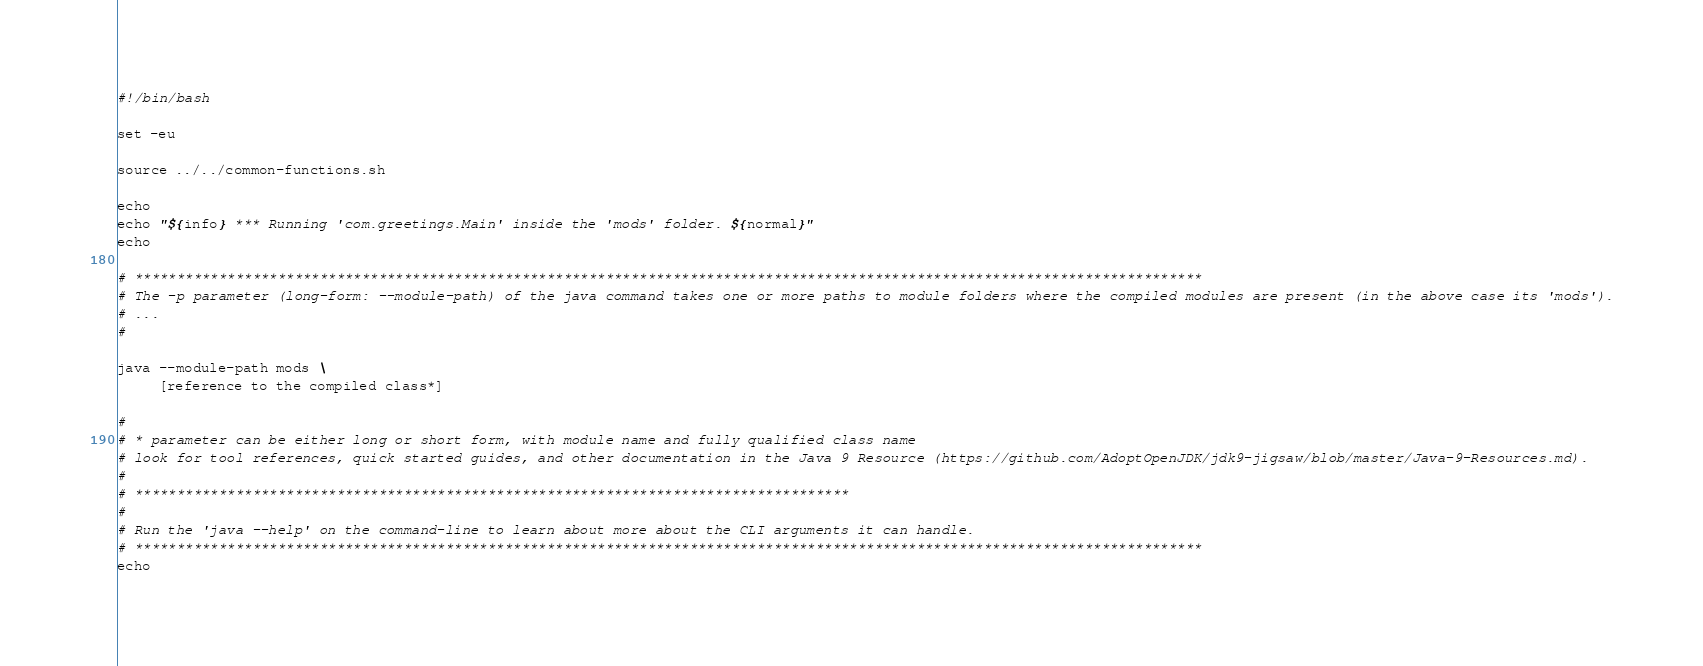Convert code to text. <code><loc_0><loc_0><loc_500><loc_500><_Bash_>#!/bin/bash

set -eu

source ../../common-functions.sh

echo 
echo "${info} *** Running 'com.greetings.Main' inside the 'mods' folder. ${normal}"
echo

# *******************************************************************************************************************************
# The -p parameter (long-form: --module-path) of the java command takes one or more paths to module folders where the compiled modules are present (in the above case its 'mods').
# ...
#

java --module-path mods \
     [reference to the compiled class*]

#
# * parameter can be either long or short form, with module name and fully qualified class name
# look for tool references, quick started guides, and other documentation in the Java 9 Resource (https://github.com/AdoptOpenJDK/jdk9-jigsaw/blob/master/Java-9-Resources.md).
#
# *************************************************************************************
#
# Run the 'java --help' on the command-line to learn about more about the CLI arguments it can handle.
# *******************************************************************************************************************************
echo
</code> 